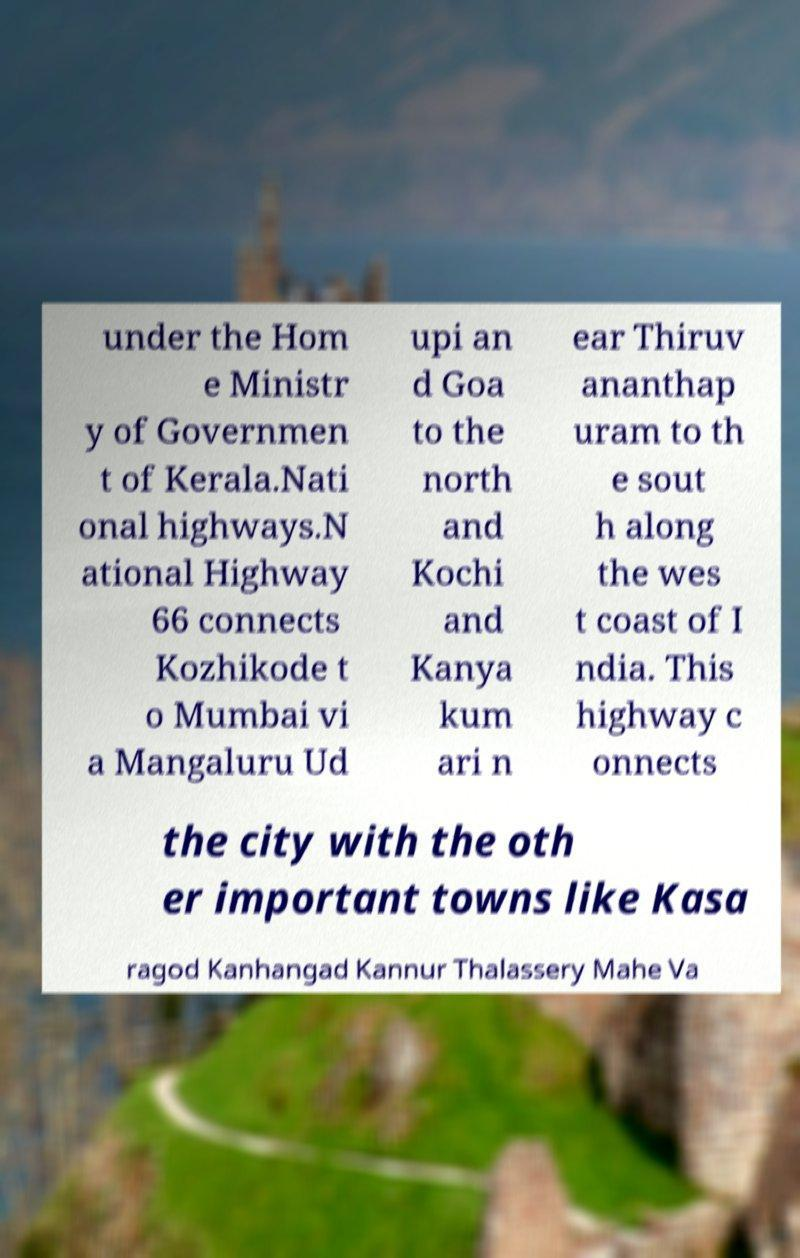I need the written content from this picture converted into text. Can you do that? under the Hom e Ministr y of Governmen t of Kerala.Nati onal highways.N ational Highway 66 connects Kozhikode t o Mumbai vi a Mangaluru Ud upi an d Goa to the north and Kochi and Kanya kum ari n ear Thiruv ananthap uram to th e sout h along the wes t coast of I ndia. This highway c onnects the city with the oth er important towns like Kasa ragod Kanhangad Kannur Thalassery Mahe Va 